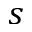Convert formula to latex. <formula><loc_0><loc_0><loc_500><loc_500>s</formula> 